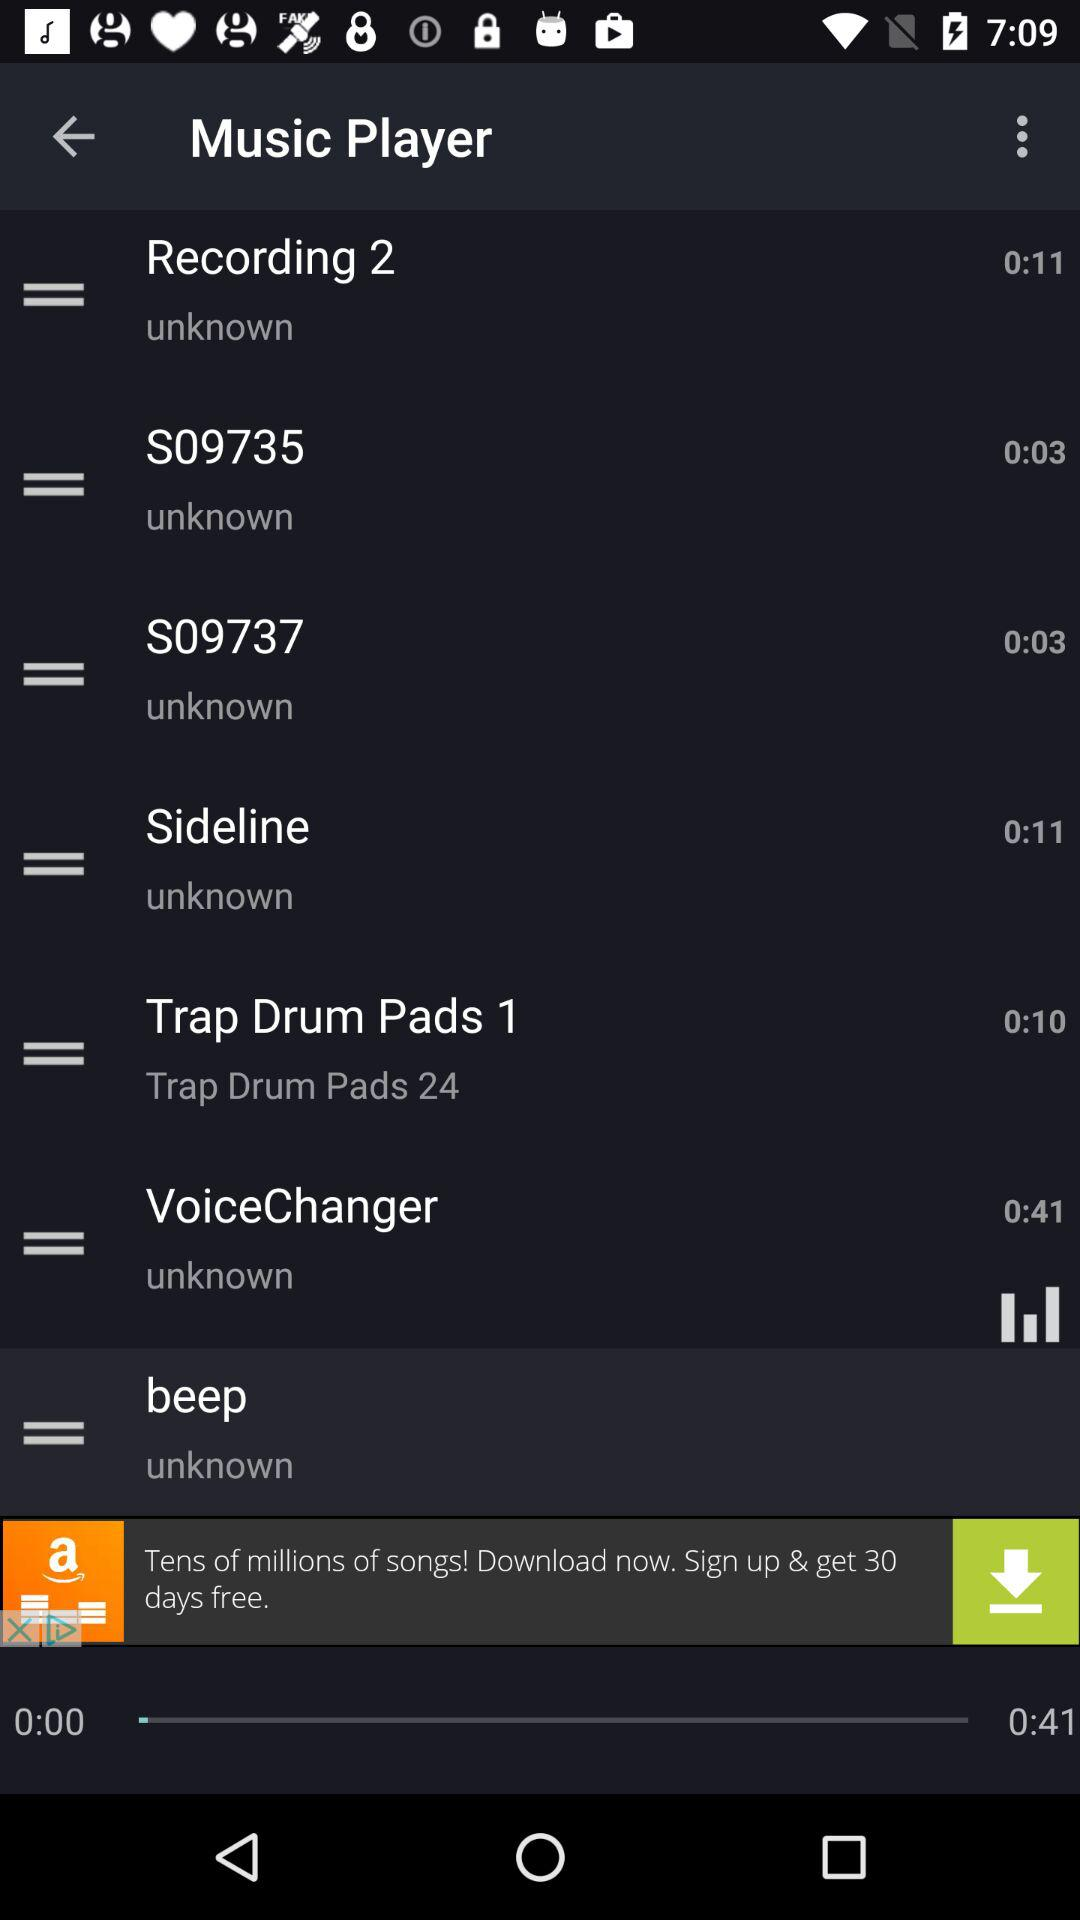Which item has the longest duration?
Answer the question using a single word or phrase. VoiceChanger 